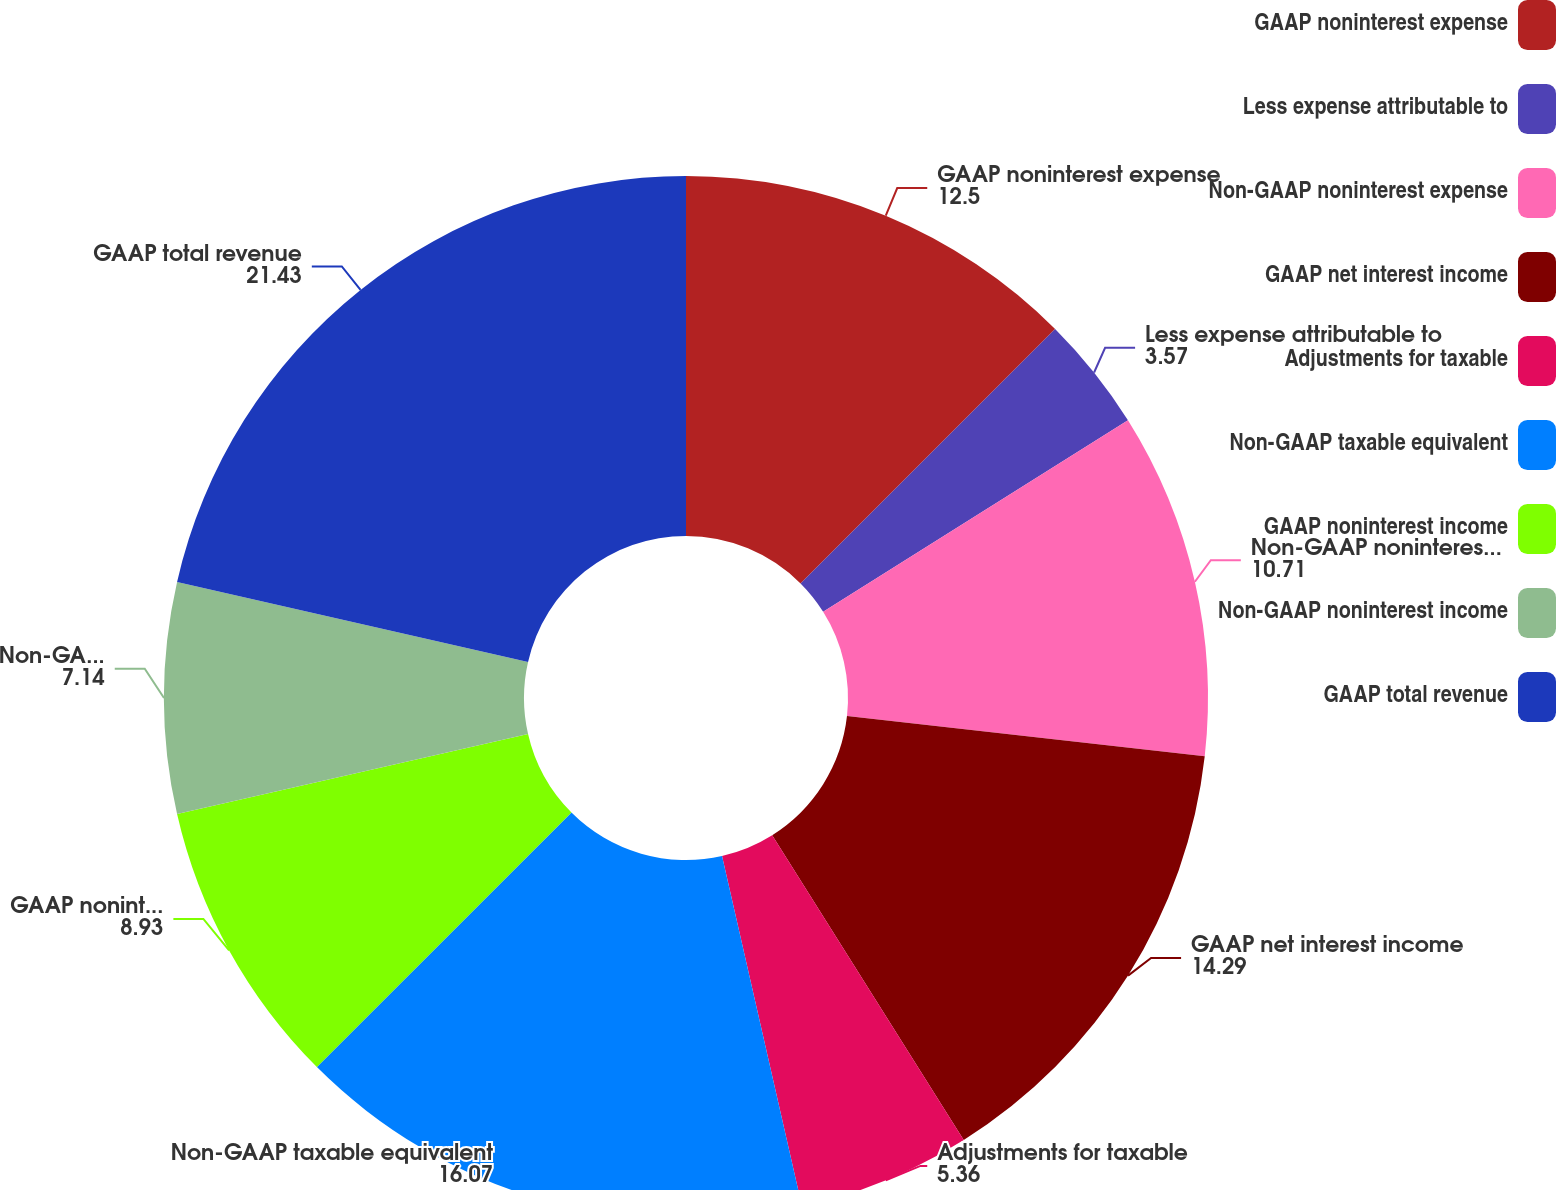<chart> <loc_0><loc_0><loc_500><loc_500><pie_chart><fcel>GAAP noninterest expense<fcel>Less expense attributable to<fcel>Non-GAAP noninterest expense<fcel>GAAP net interest income<fcel>Adjustments for taxable<fcel>Non-GAAP taxable equivalent<fcel>GAAP noninterest income<fcel>Non-GAAP noninterest income<fcel>GAAP total revenue<nl><fcel>12.5%<fcel>3.57%<fcel>10.71%<fcel>14.29%<fcel>5.36%<fcel>16.07%<fcel>8.93%<fcel>7.14%<fcel>21.43%<nl></chart> 